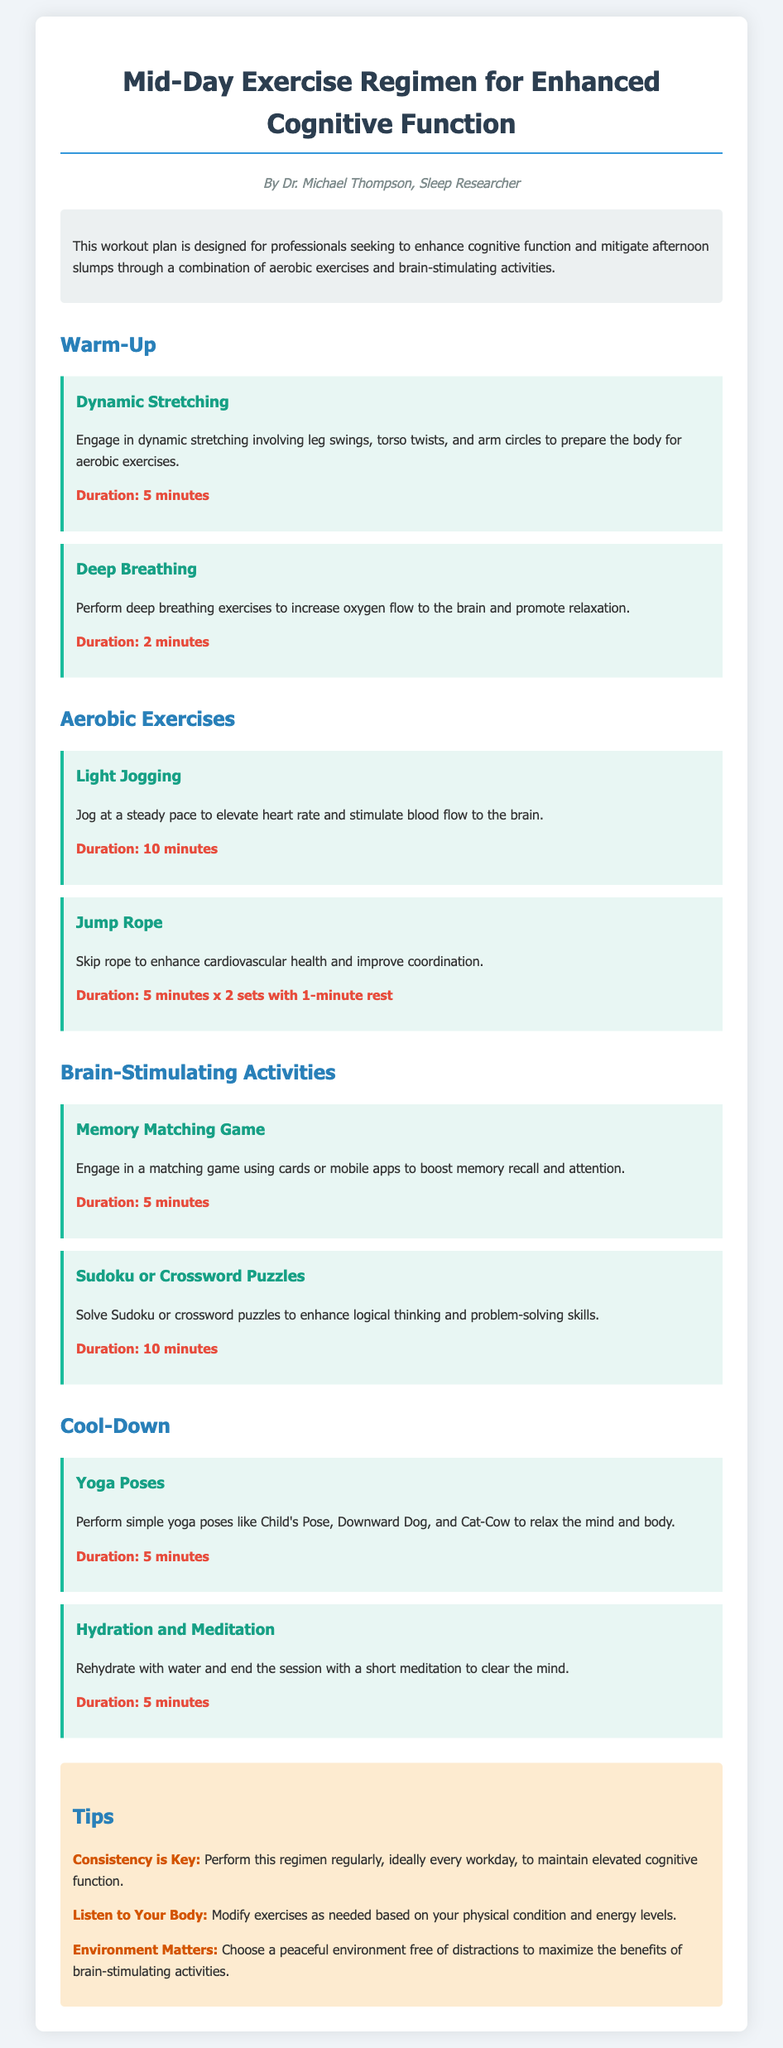What is the title of the document? The title is found in the header of the document and describes the main topic.
Answer: Mid-Day Exercise Regimen for Enhanced Cognitive Function Who is the author of the document? The author is mentioned below the title and indicates the creator of the workout plan.
Answer: Dr. Michael Thompson How long should one perform dynamic stretching? Duration information is provided for each activity, detailing how long they should take.
Answer: 5 minutes What is one brain-stimulating activity listed in the plan? The document outlines specific activities designed to stimulate brain function, and one of them is provided.
Answer: Memory Matching Game What is the total duration for Jump Rope activity? The duration is given as two sets with a specified rest period, requiring addition for a total.
Answer: 11 minutes What does the warm-up section consist of? The warm-up section includes two types of activities before the main exercises.
Answer: Dynamic Stretching and Deep Breathing What is a key tip provided in the document? Tips are outlined at the end of the document for enhancing the effectiveness of the regimen.
Answer: Consistency is Key Which yoga poses are suggested during the cool-down? The activity focuses on specific yoga poses aimed at relaxation, listed in the cool-down section.
Answer: Child's Pose, Downward Dog, and Cat-Cow 